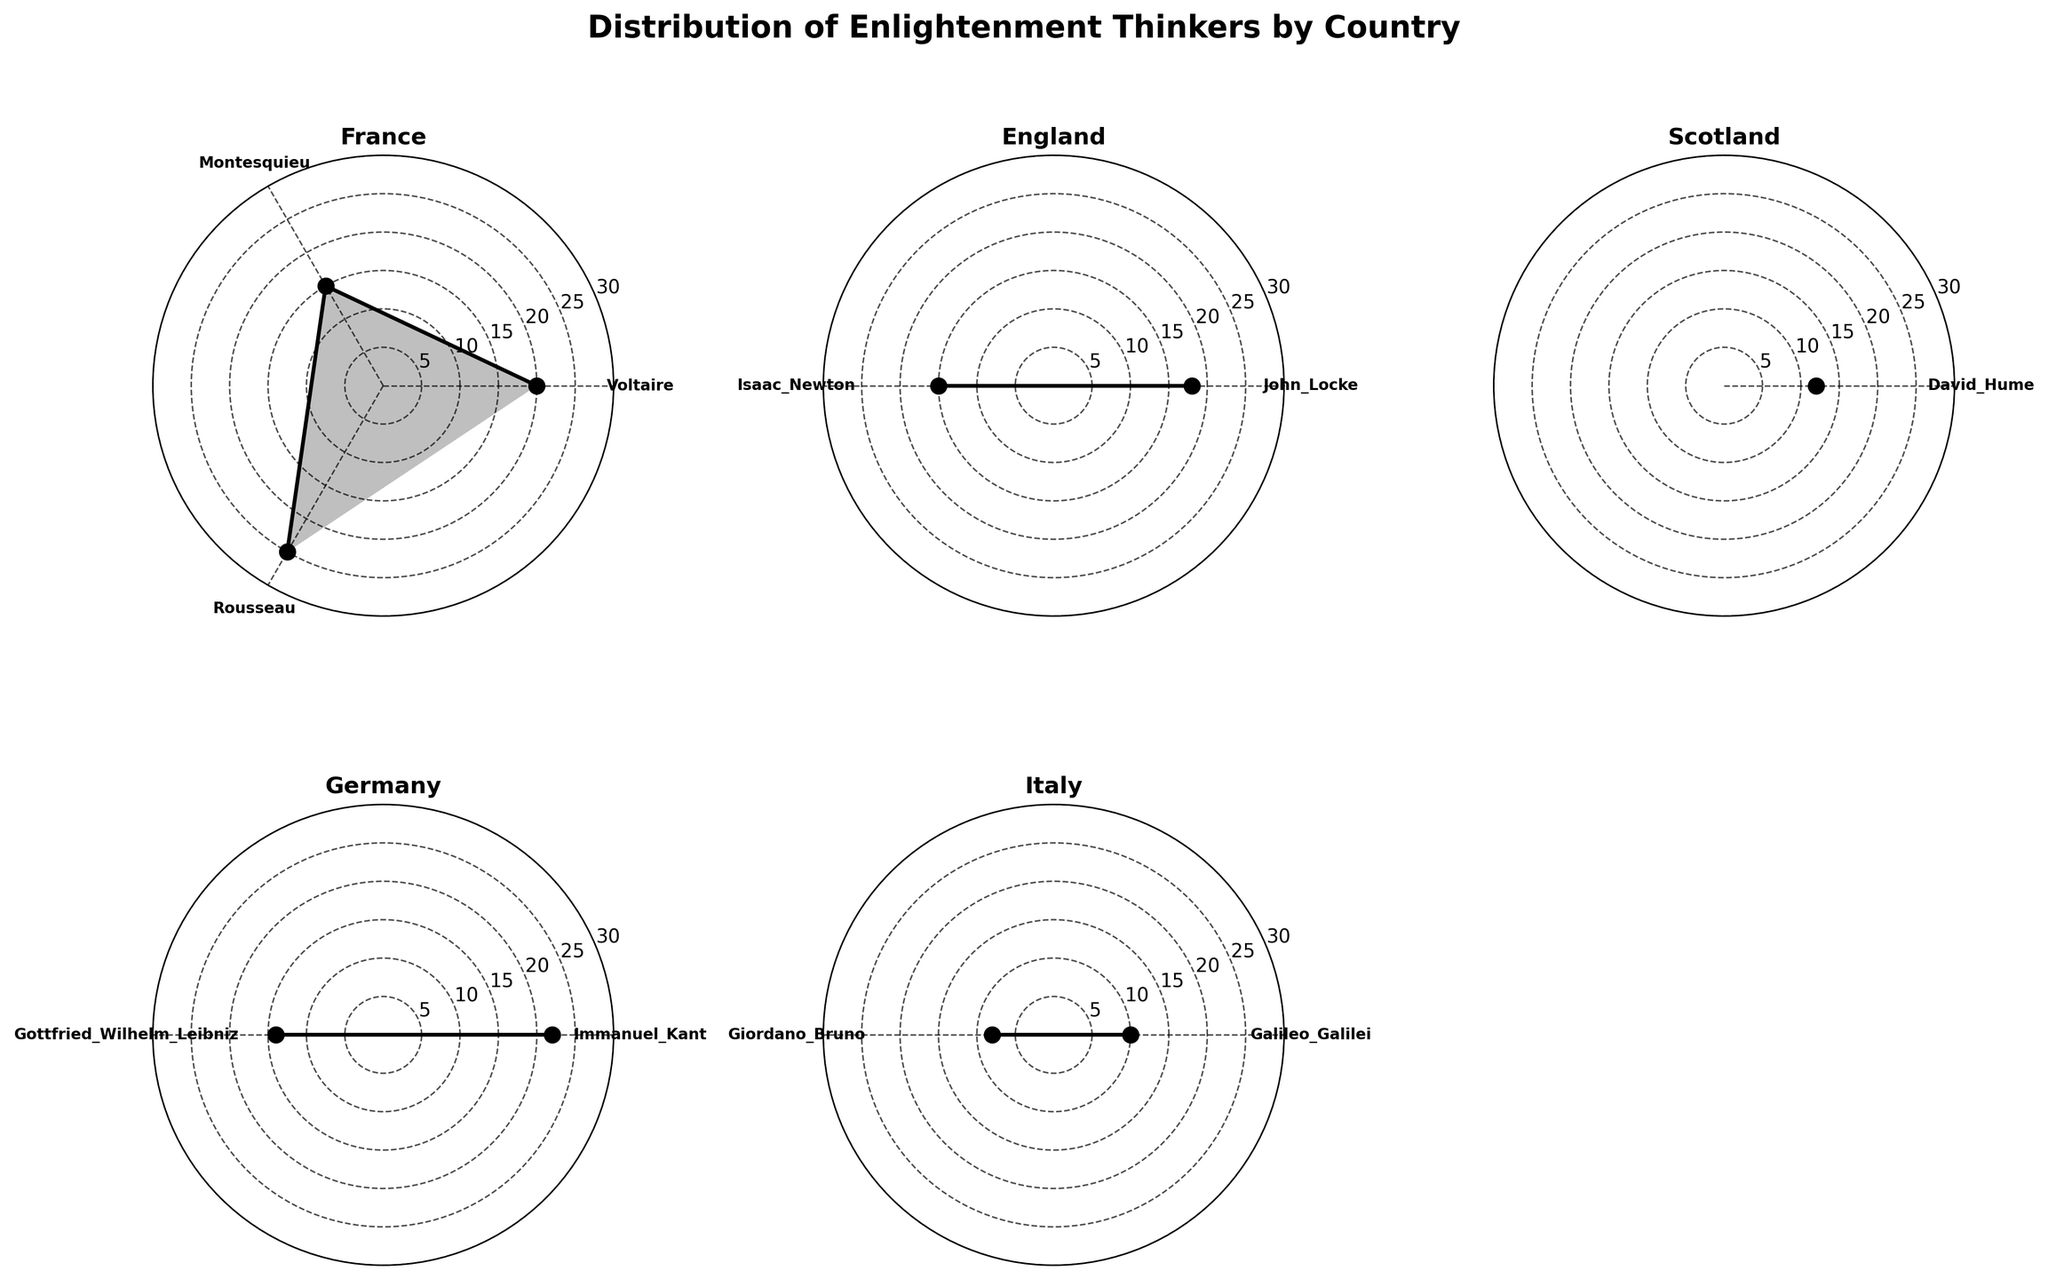What is the title of the figure? The title of the figure can be found at the top of the plot. It states the main subject of the visualization.
Answer: Distribution of Enlightenment Thinkers by Country How many countries are represented in the figure? To determine the number of countries, you can count the number of subplots that are labeled with country names.
Answer: 6 Which thinker from France has the highest number of works? Look at the subplot labeled "France" and identify the thinker with the highest value on the radial axis.
Answer: Rousseau What is the average number of works from thinkers in Germany? In the subplot for Germany, sum the number of works for both thinkers and then divide by the number of thinkers. (22 + 14) / 2 = 18
Answer: 18 Compare the number of works of Voltaire and Rousseau from France. Who has more? Locate the subplot for France and compare the radial values for Voltaire and Rousseau. Rousseau's value is higher than Voltaire's.
Answer: Rousseau Which country has a thinker with exactly 11 works? Examine the radial values of each subplot. The Netherlands has Baruch Spinoza with 11 works.
Answer: Netherlands What is the difference in number of works between Benjamin Franklin (United States) and David Hume (Scotland)? Identify the radial values for Benjamin Franklin and David Hume and calculate the difference. 12 - 9 = 3
Answer: 3 How is the spread (range) of the number of works for thinkers from Italy? In the subplot for Italy, find the minimum and maximum values and calculate the range. Max = 10 (Galileo Galilei) and Min = 8 (Giordano Bruno). 10 - 8 = 2
Answer: 2 Which country's subchart has the fewest data points? Count the number of thinkers (data points) in each subplot to find the country.
Answer: United States What is the total number of works listed for thinkers from England? Sum the radial values for all the thinkers in the England subplot. 18 (John Locke) + 15 (Isaac Newton) = 33
Answer: 33 